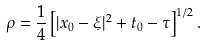<formula> <loc_0><loc_0><loc_500><loc_500>\rho = \frac { 1 } { 4 } \left [ | x _ { 0 } - \xi | ^ { 2 } + t _ { 0 } - \tau \right ] ^ { 1 / 2 } .</formula> 